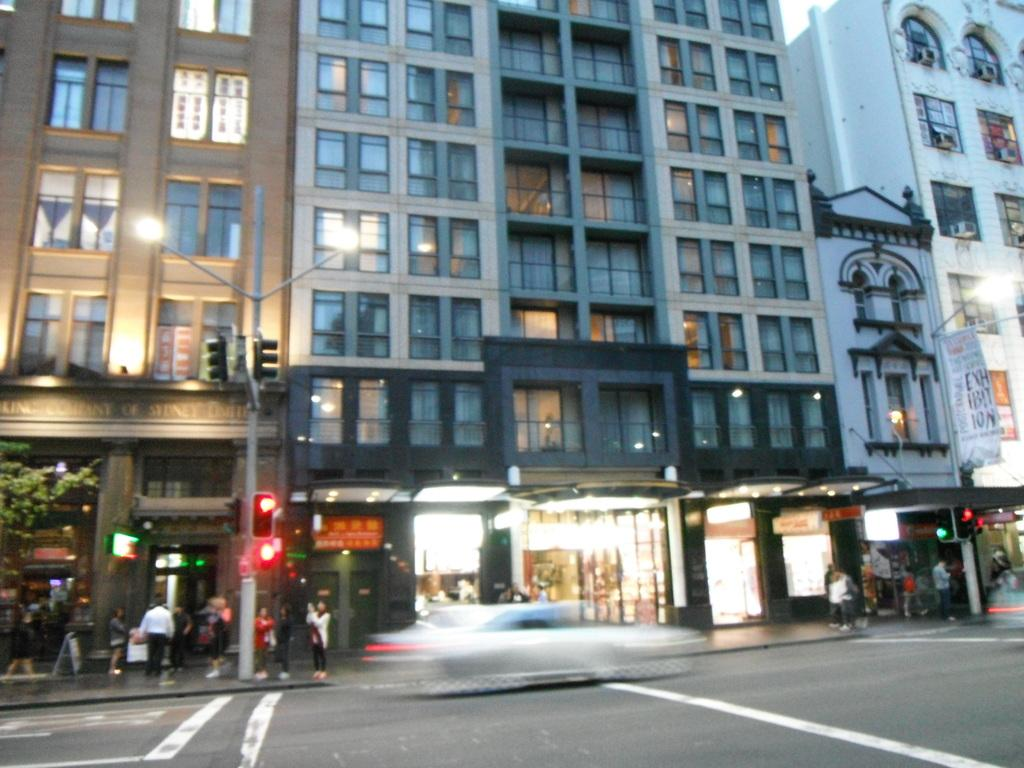What type of structures can be seen in the image? There are buildings in the image. What architectural features are present on the buildings? There are windows and doors visible on the buildings. What type of establishments can be found in the image? There are stores in the image. Are there any people present in the image? Yes, there are persons in the image. What other objects can be seen in the image? There are poles, traffic signals, and a road in the image. What type of clam is used to hold the traffic signals in the image? There are no clams present in the image; the traffic signals are attached to poles. Is there any glue visible in the image? There is no mention of glue in the image, and it is not visible in the provided facts. 